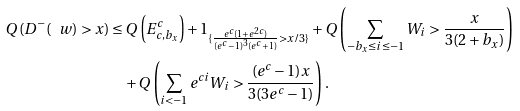<formula> <loc_0><loc_0><loc_500><loc_500>Q \left ( D ^ { - } ( \ w ) > x \right ) & \leq Q \left ( E _ { c , b _ { x } } ^ { c } \right ) + 1 _ { \{ \frac { e ^ { c } ( 1 + e ^ { 2 c } ) } { ( e ^ { c } - 1 ) ^ { 3 } ( e ^ { c } + 1 ) } > x / 3 \} } + Q \left ( \sum _ { - b _ { x } \leq i \leq - 1 } W _ { i } > \frac { x } { 3 ( 2 + b _ { x } ) } \right ) \\ & \quad + Q \left ( \sum _ { i < - 1 } e ^ { c i } W _ { i } > \frac { ( e ^ { c } - 1 ) x } { 3 ( 3 e ^ { c } - 1 ) } \right ) .</formula> 